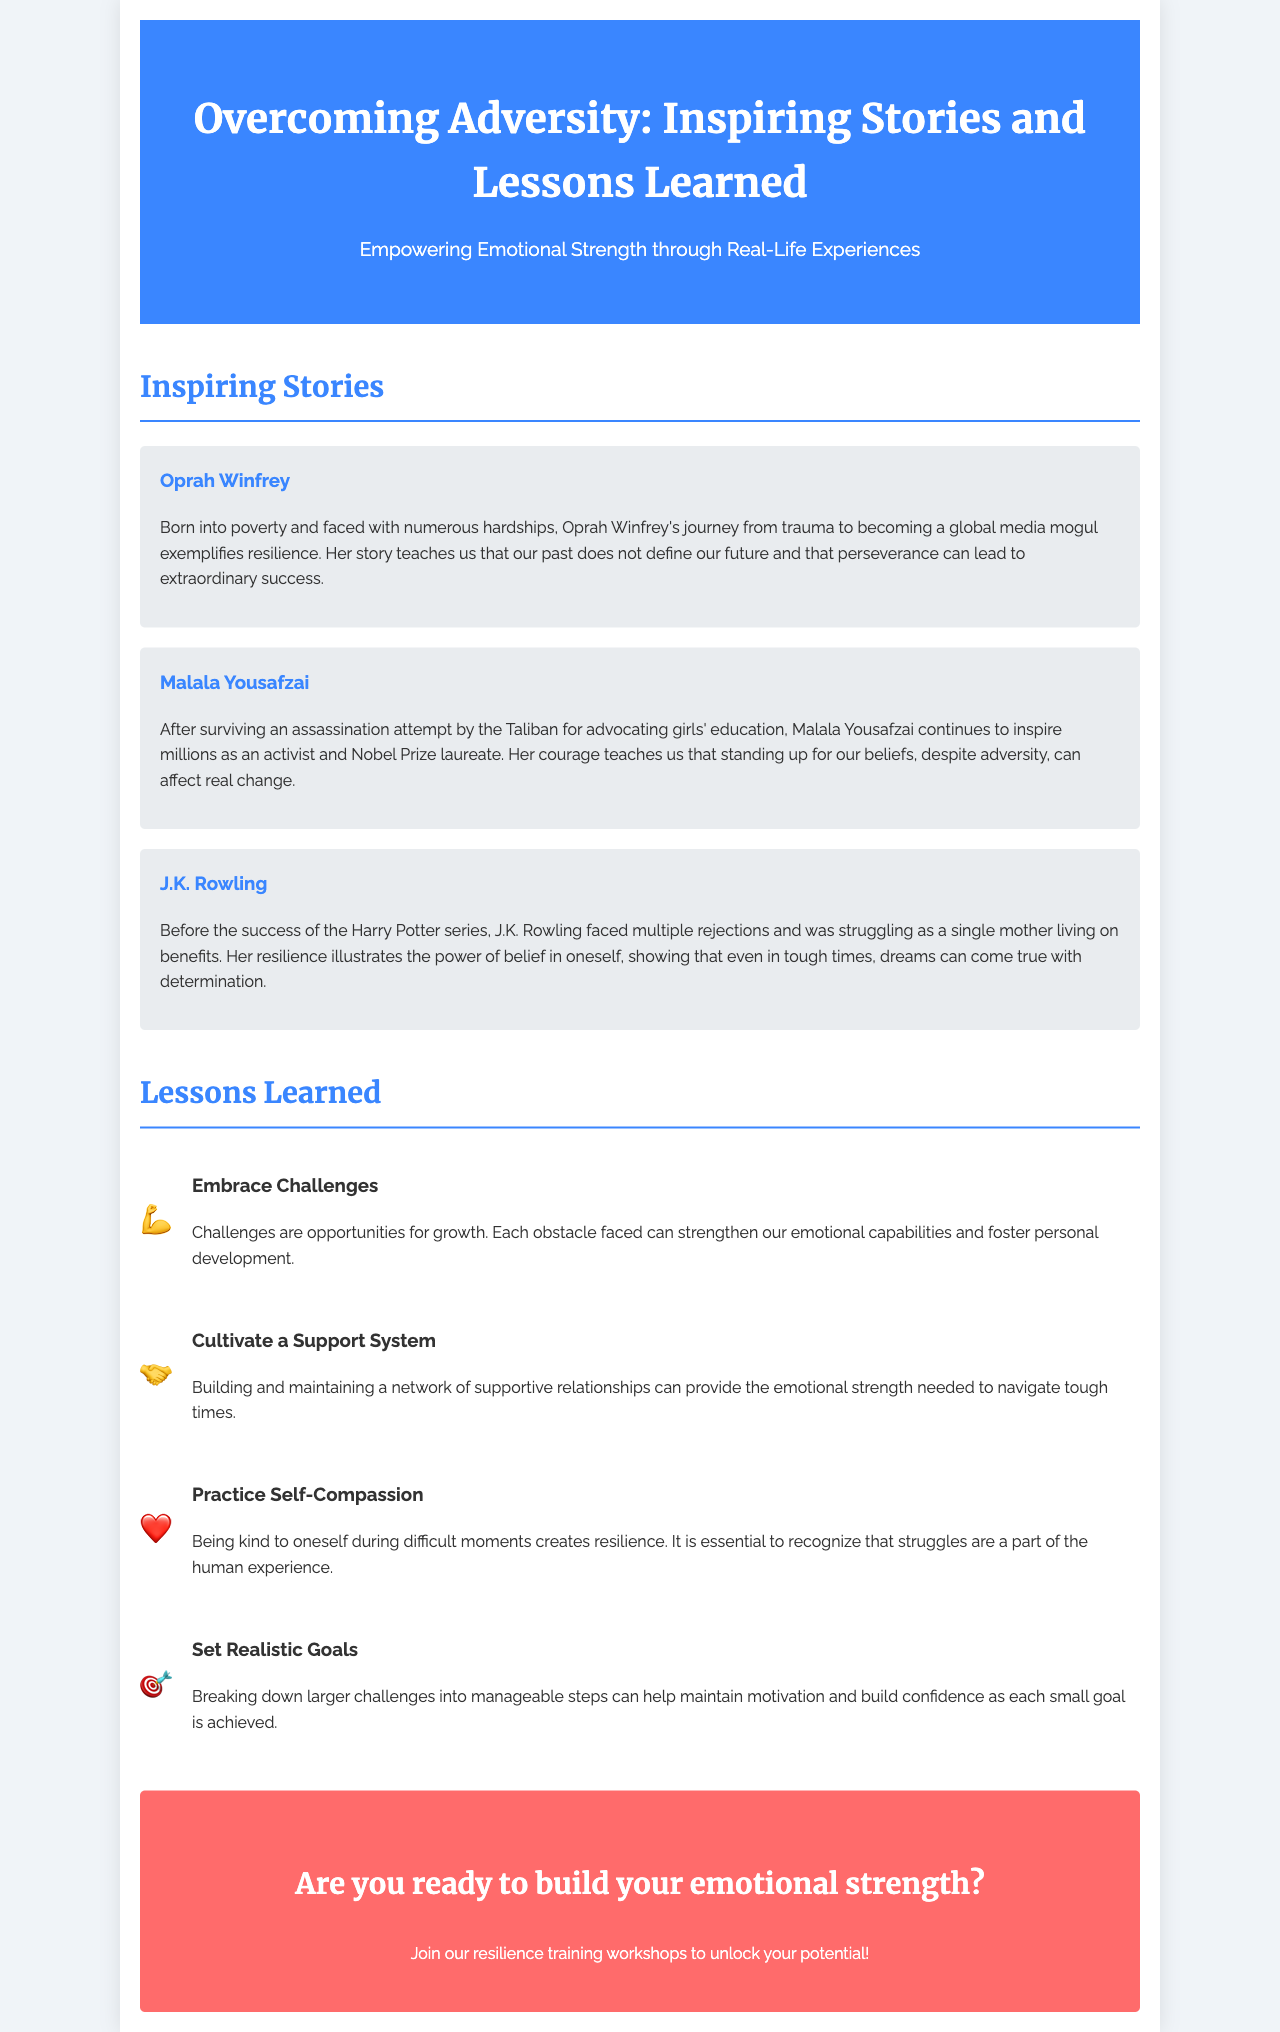What is the title of the brochure? The title of the brochure is prominently displayed at the top of the document.
Answer: Overcoming Adversity: Inspiring Stories and Lessons Learned Who is one of the inspiring figures mentioned in the brochure? The brochure lists notable individuals who have overcome adversity.
Answer: Oprah Winfrey What is a key lesson about self-compassion? The brochure provides specific lessons learned regarding resilience and emotional strength.
Answer: Being kind to oneself during difficult moments creates resilience What does Malala Yousafzai advocate for? The document includes a brief account of Malala Yousafzai's activism.
Answer: Girls' education How many inspiring stories are presented in the document? The brochure showcases three personal stories of resilience.
Answer: Three What symbol is used for the lesson about embracing challenges? The lessons in the brochure are represented with icons.
Answer: 💪 What should you do to build emotional strength according to the call to action? The call to action encourages taking a specific step.
Answer: Join our resilience training workshops What is one of the benefits of cultivating a support system? The brochure highlights the importance of having supportive relationships.
Answer: Emotional strength 